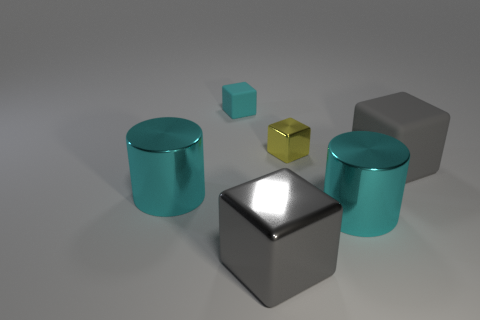Add 2 rubber things. How many objects exist? 8 Subtract all cylinders. How many objects are left? 4 Add 6 large cyan objects. How many large cyan objects are left? 8 Add 6 small yellow cubes. How many small yellow cubes exist? 7 Subtract 0 yellow cylinders. How many objects are left? 6 Subtract all gray rubber cubes. Subtract all yellow blocks. How many objects are left? 4 